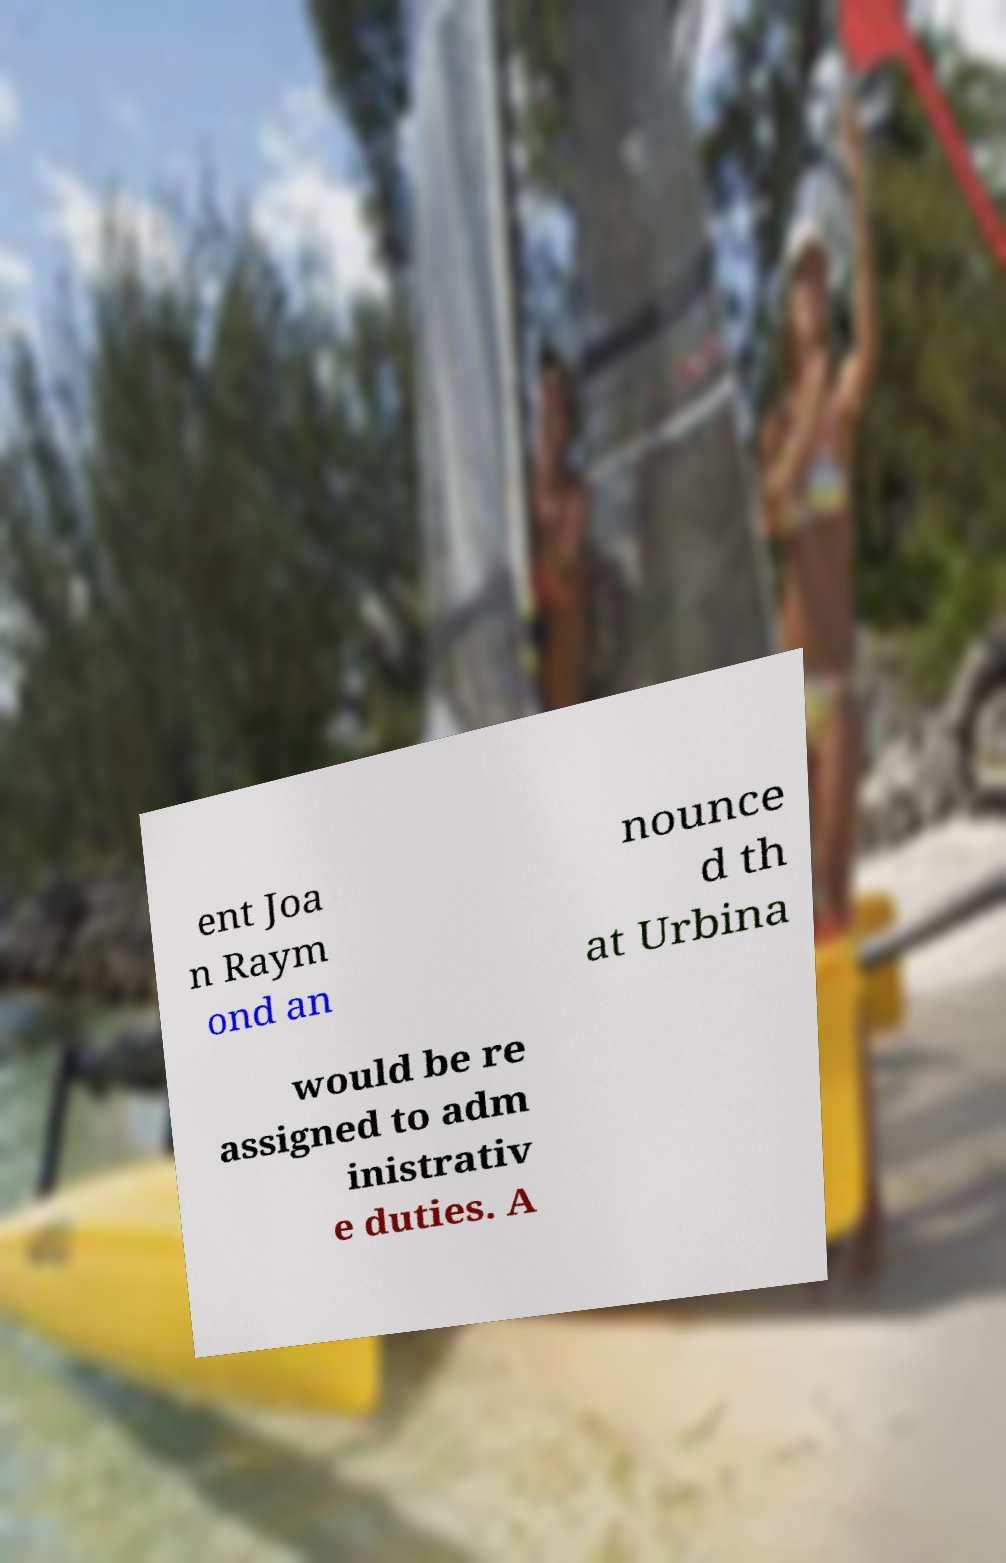Please identify and transcribe the text found in this image. ent Joa n Raym ond an nounce d th at Urbina would be re assigned to adm inistrativ e duties. A 